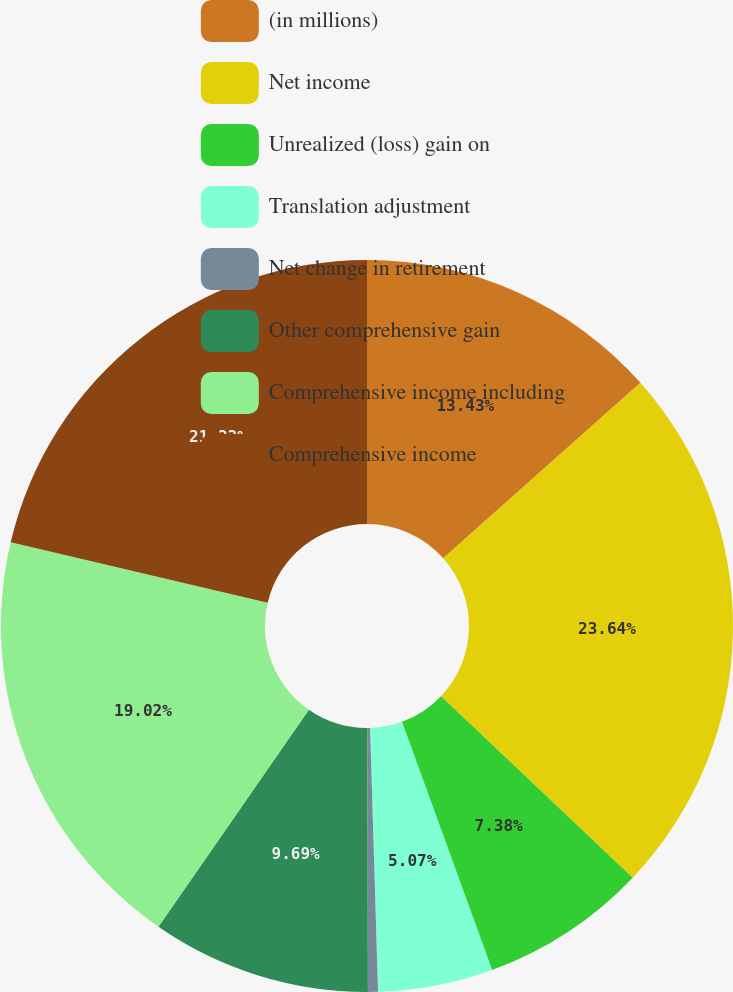<chart> <loc_0><loc_0><loc_500><loc_500><pie_chart><fcel>(in millions)<fcel>Net income<fcel>Unrealized (loss) gain on<fcel>Translation adjustment<fcel>Net change in retirement<fcel>Other comprehensive gain<fcel>Comprehensive income including<fcel>Comprehensive income<nl><fcel>13.43%<fcel>23.64%<fcel>7.38%<fcel>5.07%<fcel>0.44%<fcel>9.69%<fcel>19.02%<fcel>21.33%<nl></chart> 